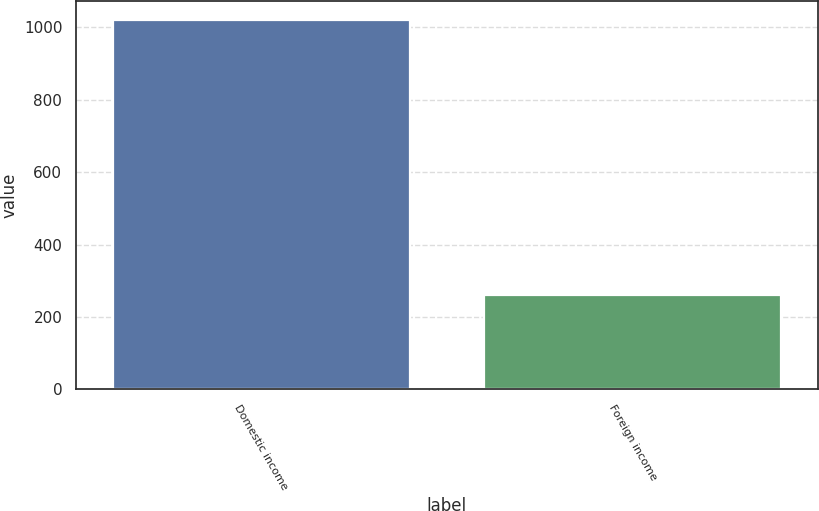Convert chart. <chart><loc_0><loc_0><loc_500><loc_500><bar_chart><fcel>Domestic income<fcel>Foreign income<nl><fcel>1021<fcel>260<nl></chart> 